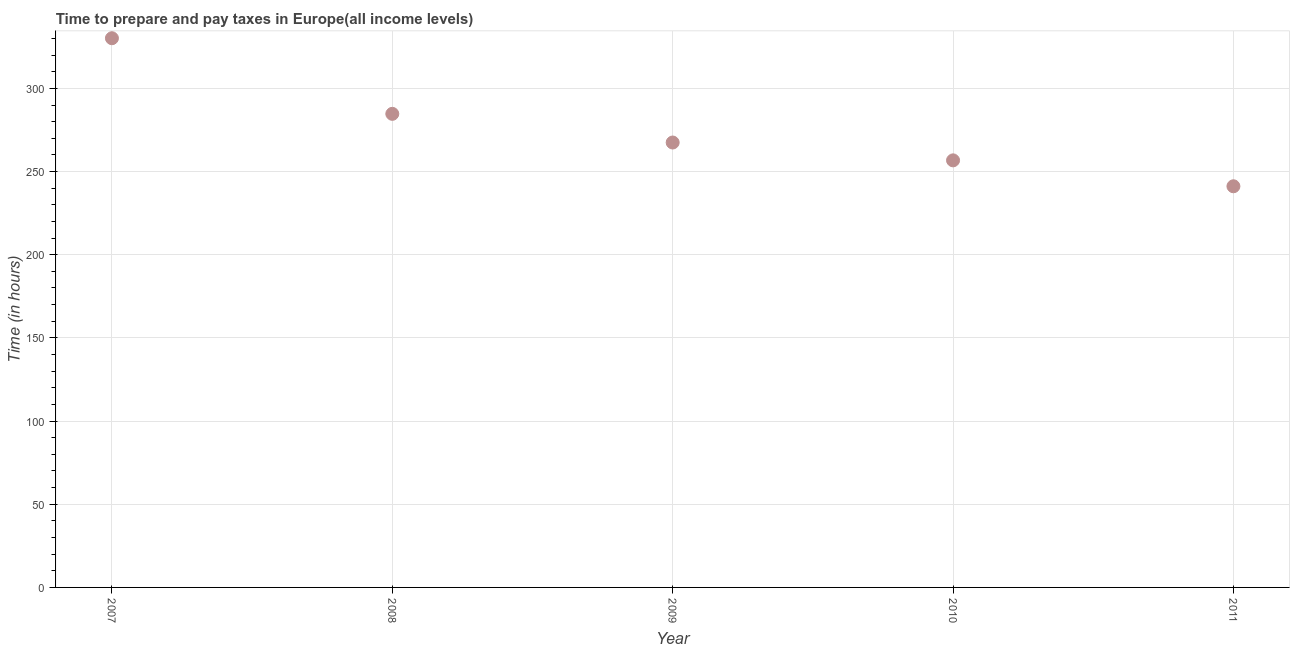What is the time to prepare and pay taxes in 2011?
Your answer should be very brief. 241.15. Across all years, what is the maximum time to prepare and pay taxes?
Provide a succinct answer. 330.14. Across all years, what is the minimum time to prepare and pay taxes?
Your answer should be very brief. 241.15. In which year was the time to prepare and pay taxes maximum?
Provide a short and direct response. 2007. What is the sum of the time to prepare and pay taxes?
Provide a succinct answer. 1380.16. What is the difference between the time to prepare and pay taxes in 2007 and 2008?
Provide a short and direct response. 45.46. What is the average time to prepare and pay taxes per year?
Provide a short and direct response. 276.03. What is the median time to prepare and pay taxes?
Ensure brevity in your answer.  267.45. In how many years, is the time to prepare and pay taxes greater than 70 hours?
Offer a very short reply. 5. Do a majority of the years between 2011 and 2008 (inclusive) have time to prepare and pay taxes greater than 20 hours?
Give a very brief answer. Yes. What is the ratio of the time to prepare and pay taxes in 2007 to that in 2009?
Give a very brief answer. 1.23. Is the time to prepare and pay taxes in 2009 less than that in 2010?
Keep it short and to the point. No. Is the difference between the time to prepare and pay taxes in 2007 and 2009 greater than the difference between any two years?
Provide a succinct answer. No. What is the difference between the highest and the second highest time to prepare and pay taxes?
Offer a terse response. 45.46. What is the difference between the highest and the lowest time to prepare and pay taxes?
Provide a short and direct response. 89. In how many years, is the time to prepare and pay taxes greater than the average time to prepare and pay taxes taken over all years?
Keep it short and to the point. 2. Does the time to prepare and pay taxes monotonically increase over the years?
Ensure brevity in your answer.  No. How many years are there in the graph?
Your response must be concise. 5. What is the difference between two consecutive major ticks on the Y-axis?
Offer a very short reply. 50. Are the values on the major ticks of Y-axis written in scientific E-notation?
Offer a very short reply. No. Does the graph contain any zero values?
Ensure brevity in your answer.  No. What is the title of the graph?
Your answer should be compact. Time to prepare and pay taxes in Europe(all income levels). What is the label or title of the Y-axis?
Offer a terse response. Time (in hours). What is the Time (in hours) in 2007?
Offer a terse response. 330.14. What is the Time (in hours) in 2008?
Offer a terse response. 284.69. What is the Time (in hours) in 2009?
Make the answer very short. 267.45. What is the Time (in hours) in 2010?
Provide a succinct answer. 256.72. What is the Time (in hours) in 2011?
Provide a succinct answer. 241.15. What is the difference between the Time (in hours) in 2007 and 2008?
Give a very brief answer. 45.46. What is the difference between the Time (in hours) in 2007 and 2009?
Your answer should be very brief. 62.69. What is the difference between the Time (in hours) in 2007 and 2010?
Offer a very short reply. 73.42. What is the difference between the Time (in hours) in 2007 and 2011?
Your answer should be very brief. 89. What is the difference between the Time (in hours) in 2008 and 2009?
Ensure brevity in your answer.  17.24. What is the difference between the Time (in hours) in 2008 and 2010?
Keep it short and to the point. 27.97. What is the difference between the Time (in hours) in 2008 and 2011?
Ensure brevity in your answer.  43.54. What is the difference between the Time (in hours) in 2009 and 2010?
Provide a succinct answer. 10.73. What is the difference between the Time (in hours) in 2009 and 2011?
Your answer should be compact. 26.3. What is the difference between the Time (in hours) in 2010 and 2011?
Provide a short and direct response. 15.57. What is the ratio of the Time (in hours) in 2007 to that in 2008?
Offer a very short reply. 1.16. What is the ratio of the Time (in hours) in 2007 to that in 2009?
Provide a short and direct response. 1.23. What is the ratio of the Time (in hours) in 2007 to that in 2010?
Provide a succinct answer. 1.29. What is the ratio of the Time (in hours) in 2007 to that in 2011?
Make the answer very short. 1.37. What is the ratio of the Time (in hours) in 2008 to that in 2009?
Your answer should be compact. 1.06. What is the ratio of the Time (in hours) in 2008 to that in 2010?
Your response must be concise. 1.11. What is the ratio of the Time (in hours) in 2008 to that in 2011?
Give a very brief answer. 1.18. What is the ratio of the Time (in hours) in 2009 to that in 2010?
Make the answer very short. 1.04. What is the ratio of the Time (in hours) in 2009 to that in 2011?
Provide a succinct answer. 1.11. What is the ratio of the Time (in hours) in 2010 to that in 2011?
Make the answer very short. 1.06. 